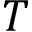Convert formula to latex. <formula><loc_0><loc_0><loc_500><loc_500>T</formula> 